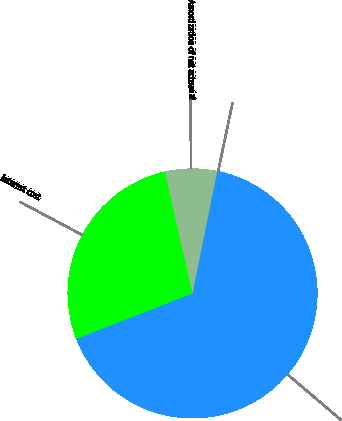Convert chart to OTSL. <chart><loc_0><loc_0><loc_500><loc_500><pie_chart><fcel>(Dollars in millions)<fcel>Interest cost<fcel>Amortization of net actuarial<fcel>Discount rate<nl><fcel>65.68%<fcel>27.38%<fcel>6.74%<fcel>0.2%<nl></chart> 